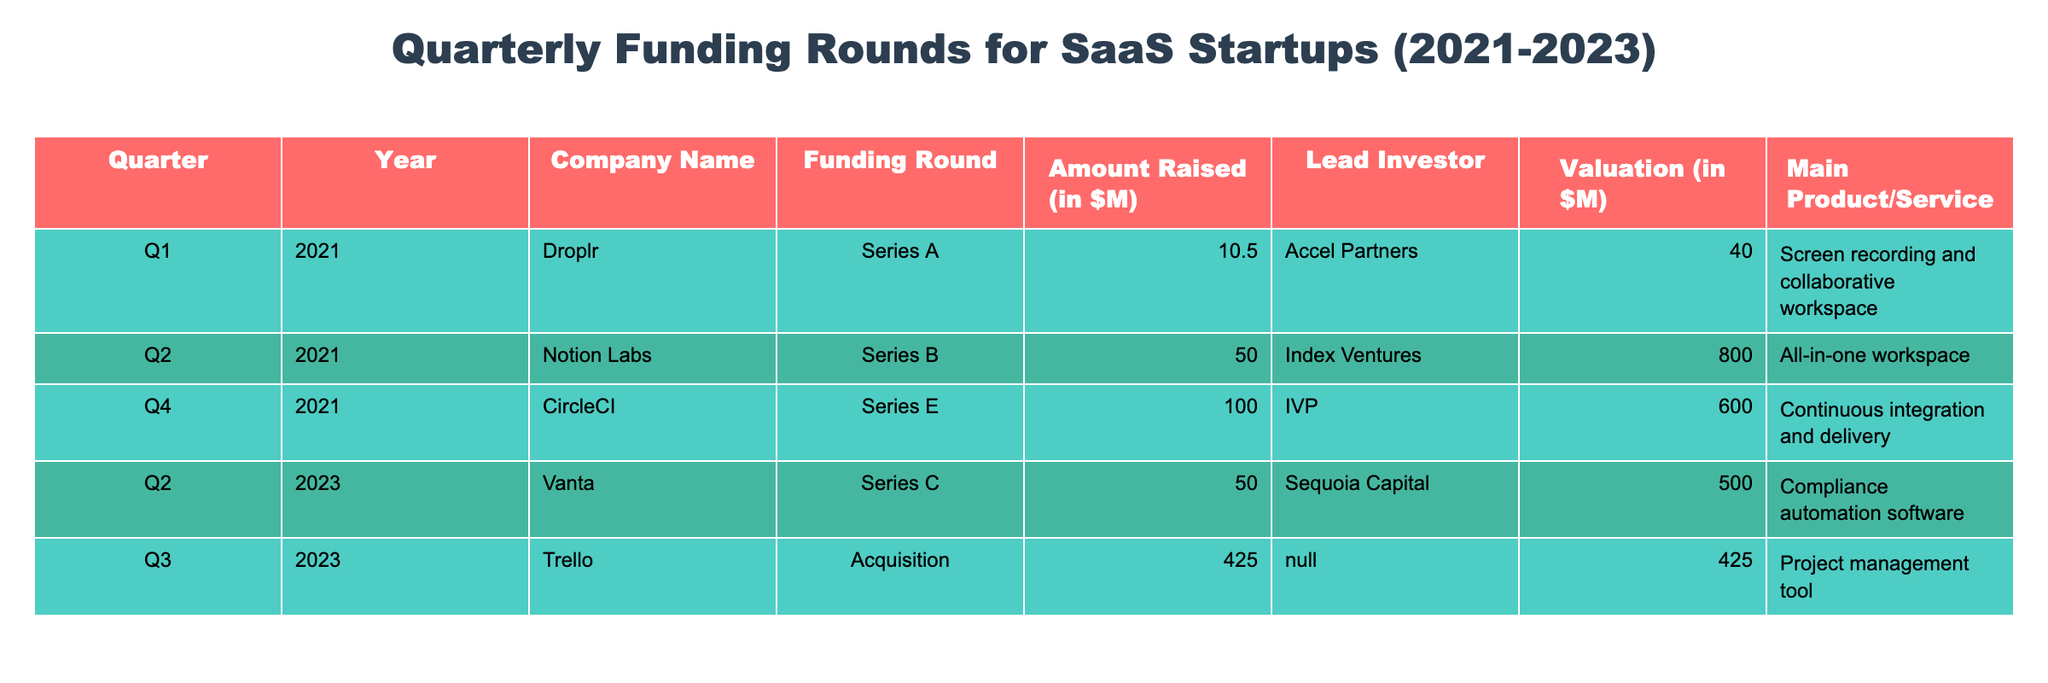What is the total amount raised in Q2 2021? From the table, there are no other funding rounds listed for Q2 2021 except for Notion Labs, which raised 50.0 million dollars. Thus, the total amount raised in that quarter is directly this value.
Answer: 50.0 million dollars Which company raised the highest funding amount? Looking at the amounts raised by each company, Trello raised 425.0 million dollars, which is greater than the amounts raised by any other company listed in the table.
Answer: Trello Did CircleCI experience an acquisition? The table indicates that CircleCI's funding round was labeled as Series E, not an acquisition. Hence, this statement is false.
Answer: No Which round did Vanta participate in, and how much did they raise? Vanta participated in Series C in Q2 2023, raising an amount of 50.0 million dollars. This information is directly taken from the corresponding row in the table.
Answer: Series C, 50.0 million dollars What is the average amount raised in 2021? To calculate the average of the amounts raised in 2021, we first sum the amounts (10.5 + 50.0 + 100.0 = 160.5) and then divide by the number of funding rounds in that year (which is 3). The average is therefore 160.5 million dollars divided by 3, which equals 53.5 million dollars.
Answer: 53.5 million dollars How many funding rounds are listed for 2023? The table shows two funding entries for 2023: one for Vanta (Series C) and one for Trello (Acquisition). Therefore, the count of funding rounds for 2023 is 2.
Answer: 2 Is the valuation of Notion Labs greater than 500 million dollars? The valuation for Notion Labs, as presented in the table, is 800.0 million dollars, which is indeed greater than 500 million dollars. So, this statement is true.
Answer: Yes What is the total amount raised from all funding rounds in Q3 2023? There is only one funding entry listed for Q3 2023 for Trello, which raised 425.0 million dollars. Therefore, the total amount raised in that quarter is simply 425.0 million dollars.
Answer: 425.0 million dollars Which investor led the largest funding round, and what was the amount? Analyzing the table, the largest funding amount is attributed to Trello at 425.0 million dollars; however, there is no leading investor listed for that round (N/A). The largest funding amount with an investor is CircleCI at 100.0 million dollars led by IVP.
Answer: IVP, 100.0 million dollars 